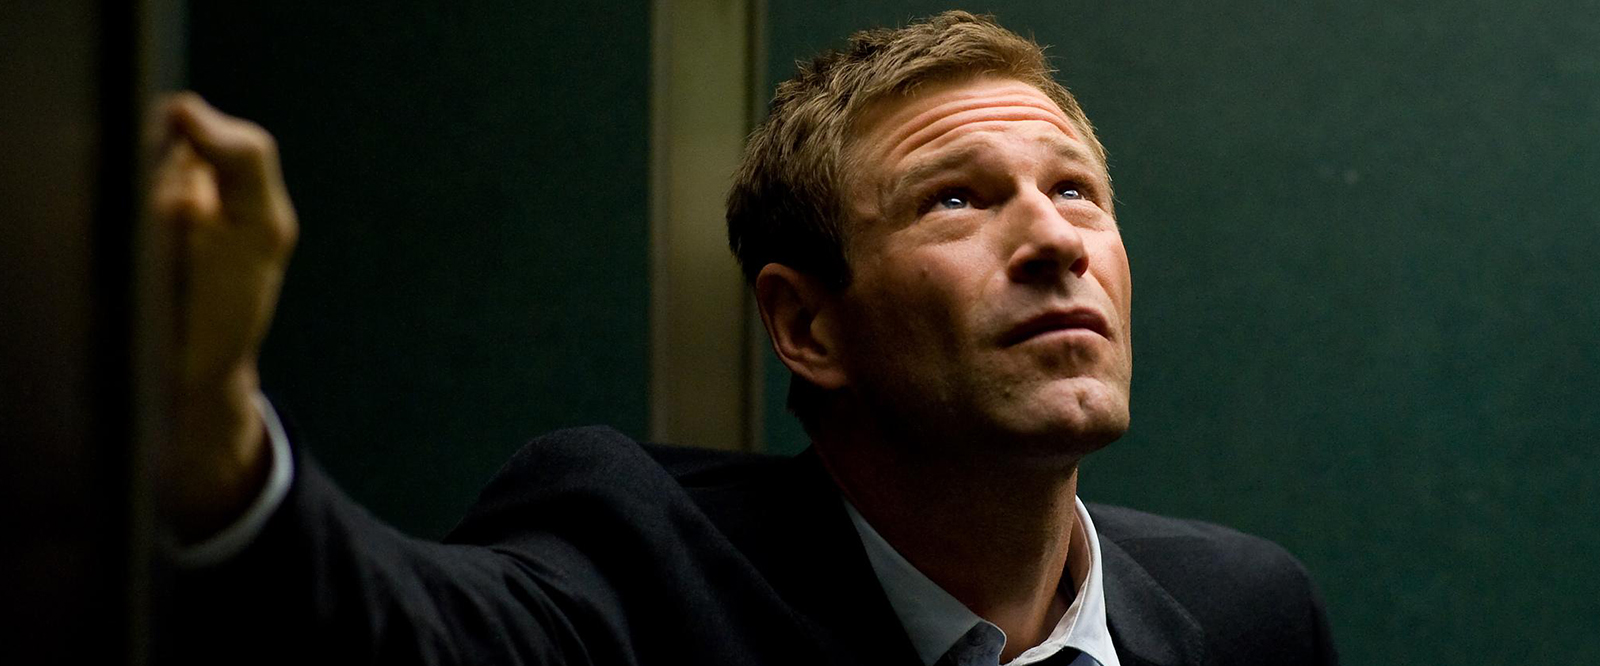What emotions does the man in the image seem to be experiencing? The man's furrowed brow and upward gaze, combined with the slight opening of the mouth, convey a complex blend of concern, contemplation, and anticipation as if he is deeply contemplating a significant issue or is expectant of an impending event. 